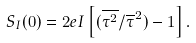<formula> <loc_0><loc_0><loc_500><loc_500>S _ { I } ( 0 ) = 2 e I \left [ ( \overline { \tau ^ { 2 } } / \overline { \tau } ^ { 2 } ) - 1 \right ] .</formula> 